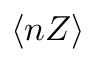Convert formula to latex. <formula><loc_0><loc_0><loc_500><loc_500>\langle n Z \rangle</formula> 